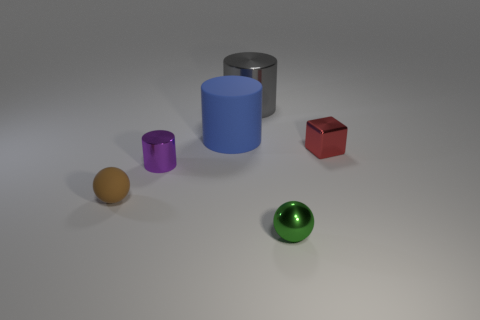Add 4 purple cylinders. How many objects exist? 10 Subtract all balls. How many objects are left? 4 Subtract 0 green blocks. How many objects are left? 6 Subtract all small green shiny things. Subtract all green balls. How many objects are left? 4 Add 3 big metallic cylinders. How many big metallic cylinders are left? 4 Add 2 tiny brown things. How many tiny brown things exist? 3 